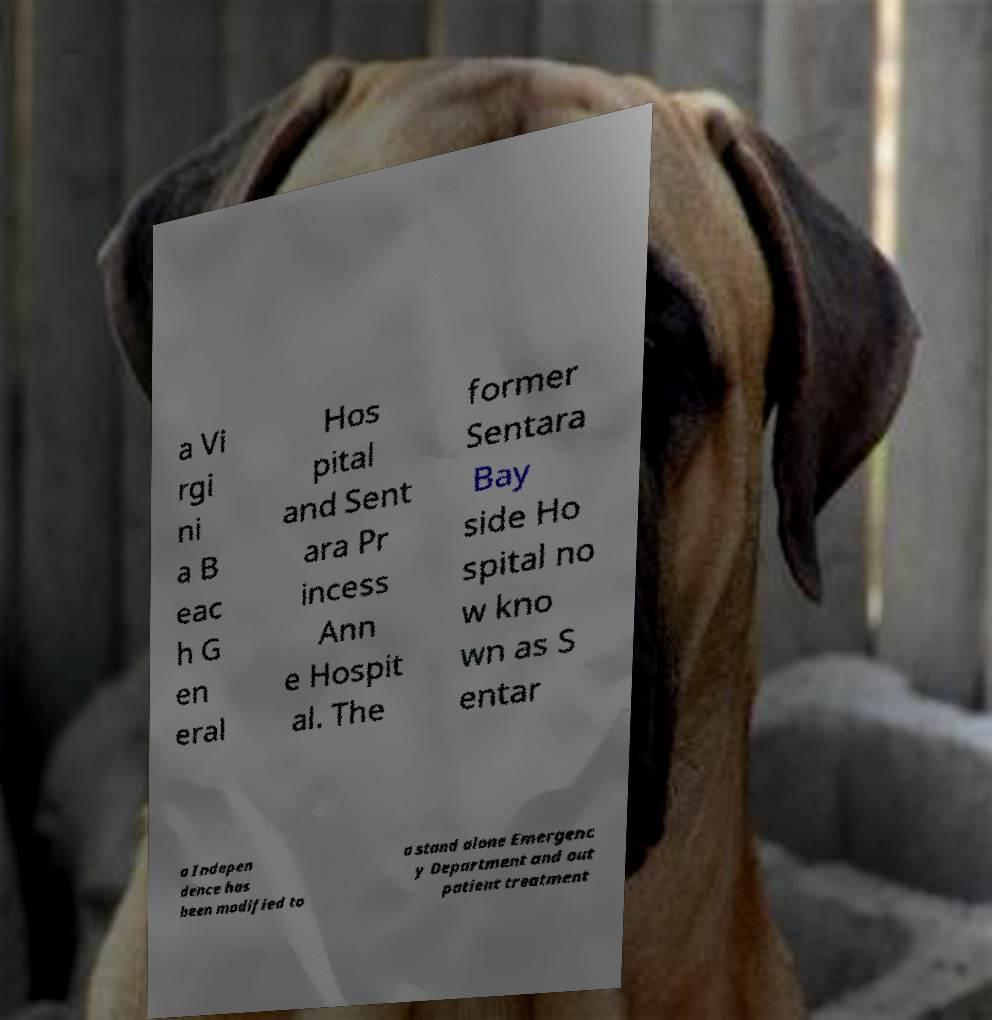Can you read and provide the text displayed in the image?This photo seems to have some interesting text. Can you extract and type it out for me? a Vi rgi ni a B eac h G en eral Hos pital and Sent ara Pr incess Ann e Hospit al. The former Sentara Bay side Ho spital no w kno wn as S entar a Indepen dence has been modified to a stand alone Emergenc y Department and out patient treatment 